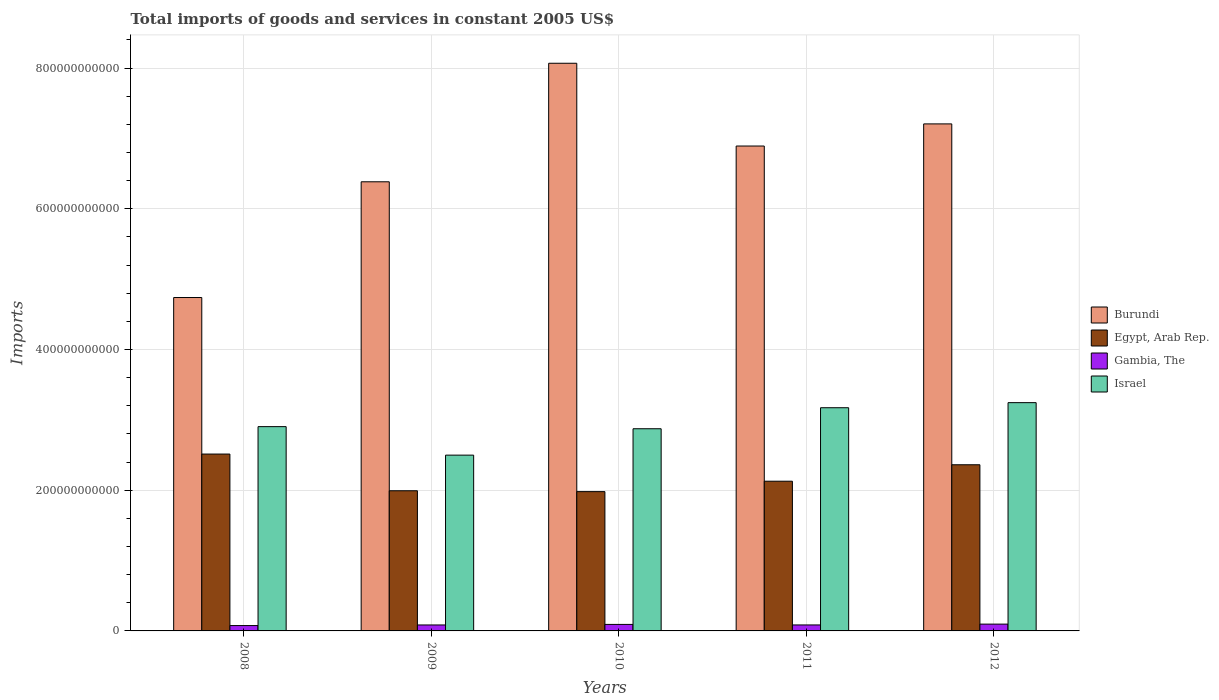How many different coloured bars are there?
Keep it short and to the point. 4. How many groups of bars are there?
Offer a terse response. 5. How many bars are there on the 5th tick from the right?
Keep it short and to the point. 4. What is the total imports of goods and services in Burundi in 2011?
Ensure brevity in your answer.  6.89e+11. Across all years, what is the maximum total imports of goods and services in Israel?
Your answer should be compact. 3.24e+11. Across all years, what is the minimum total imports of goods and services in Egypt, Arab Rep.?
Ensure brevity in your answer.  1.98e+11. In which year was the total imports of goods and services in Israel maximum?
Provide a short and direct response. 2012. What is the total total imports of goods and services in Egypt, Arab Rep. in the graph?
Your response must be concise. 1.10e+12. What is the difference between the total imports of goods and services in Israel in 2011 and that in 2012?
Give a very brief answer. -7.21e+09. What is the difference between the total imports of goods and services in Gambia, The in 2009 and the total imports of goods and services in Egypt, Arab Rep. in 2012?
Offer a terse response. -2.28e+11. What is the average total imports of goods and services in Egypt, Arab Rep. per year?
Your response must be concise. 2.19e+11. In the year 2009, what is the difference between the total imports of goods and services in Gambia, The and total imports of goods and services in Egypt, Arab Rep.?
Provide a succinct answer. -1.91e+11. In how many years, is the total imports of goods and services in Israel greater than 440000000000 US$?
Offer a terse response. 0. What is the ratio of the total imports of goods and services in Gambia, The in 2009 to that in 2012?
Keep it short and to the point. 0.87. What is the difference between the highest and the second highest total imports of goods and services in Egypt, Arab Rep.?
Provide a succinct answer. 1.52e+1. What is the difference between the highest and the lowest total imports of goods and services in Burundi?
Make the answer very short. 3.33e+11. In how many years, is the total imports of goods and services in Israel greater than the average total imports of goods and services in Israel taken over all years?
Your answer should be compact. 2. Is the sum of the total imports of goods and services in Egypt, Arab Rep. in 2008 and 2010 greater than the maximum total imports of goods and services in Burundi across all years?
Your response must be concise. No. Is it the case that in every year, the sum of the total imports of goods and services in Gambia, The and total imports of goods and services in Israel is greater than the sum of total imports of goods and services in Burundi and total imports of goods and services in Egypt, Arab Rep.?
Provide a succinct answer. No. What does the 3rd bar from the left in 2010 represents?
Offer a terse response. Gambia, The. What does the 3rd bar from the right in 2011 represents?
Your response must be concise. Egypt, Arab Rep. How many bars are there?
Offer a terse response. 20. What is the difference between two consecutive major ticks on the Y-axis?
Ensure brevity in your answer.  2.00e+11. Are the values on the major ticks of Y-axis written in scientific E-notation?
Ensure brevity in your answer.  No. Does the graph contain grids?
Keep it short and to the point. Yes. What is the title of the graph?
Offer a terse response. Total imports of goods and services in constant 2005 US$. Does "Belgium" appear as one of the legend labels in the graph?
Offer a terse response. No. What is the label or title of the Y-axis?
Your answer should be very brief. Imports. What is the Imports of Burundi in 2008?
Provide a succinct answer. 4.74e+11. What is the Imports in Egypt, Arab Rep. in 2008?
Provide a short and direct response. 2.51e+11. What is the Imports in Gambia, The in 2008?
Provide a short and direct response. 7.61e+09. What is the Imports in Israel in 2008?
Offer a terse response. 2.90e+11. What is the Imports in Burundi in 2009?
Provide a short and direct response. 6.38e+11. What is the Imports of Egypt, Arab Rep. in 2009?
Offer a very short reply. 1.99e+11. What is the Imports in Gambia, The in 2009?
Offer a terse response. 8.47e+09. What is the Imports of Israel in 2009?
Provide a short and direct response. 2.50e+11. What is the Imports of Burundi in 2010?
Offer a terse response. 8.07e+11. What is the Imports in Egypt, Arab Rep. in 2010?
Ensure brevity in your answer.  1.98e+11. What is the Imports in Gambia, The in 2010?
Your answer should be compact. 9.24e+09. What is the Imports in Israel in 2010?
Ensure brevity in your answer.  2.87e+11. What is the Imports of Burundi in 2011?
Provide a succinct answer. 6.89e+11. What is the Imports in Egypt, Arab Rep. in 2011?
Make the answer very short. 2.13e+11. What is the Imports of Gambia, The in 2011?
Your response must be concise. 8.50e+09. What is the Imports in Israel in 2011?
Keep it short and to the point. 3.17e+11. What is the Imports of Burundi in 2012?
Your answer should be compact. 7.21e+11. What is the Imports in Egypt, Arab Rep. in 2012?
Your answer should be very brief. 2.36e+11. What is the Imports of Gambia, The in 2012?
Offer a very short reply. 9.68e+09. What is the Imports in Israel in 2012?
Provide a succinct answer. 3.24e+11. Across all years, what is the maximum Imports of Burundi?
Provide a succinct answer. 8.07e+11. Across all years, what is the maximum Imports in Egypt, Arab Rep.?
Make the answer very short. 2.51e+11. Across all years, what is the maximum Imports in Gambia, The?
Make the answer very short. 9.68e+09. Across all years, what is the maximum Imports in Israel?
Offer a very short reply. 3.24e+11. Across all years, what is the minimum Imports of Burundi?
Keep it short and to the point. 4.74e+11. Across all years, what is the minimum Imports in Egypt, Arab Rep.?
Your response must be concise. 1.98e+11. Across all years, what is the minimum Imports in Gambia, The?
Provide a short and direct response. 7.61e+09. Across all years, what is the minimum Imports of Israel?
Ensure brevity in your answer.  2.50e+11. What is the total Imports of Burundi in the graph?
Offer a very short reply. 3.33e+12. What is the total Imports in Egypt, Arab Rep. in the graph?
Give a very brief answer. 1.10e+12. What is the total Imports of Gambia, The in the graph?
Ensure brevity in your answer.  4.35e+1. What is the total Imports in Israel in the graph?
Your answer should be very brief. 1.47e+12. What is the difference between the Imports in Burundi in 2008 and that in 2009?
Give a very brief answer. -1.64e+11. What is the difference between the Imports in Egypt, Arab Rep. in 2008 and that in 2009?
Your answer should be very brief. 5.22e+1. What is the difference between the Imports of Gambia, The in 2008 and that in 2009?
Offer a very short reply. -8.61e+08. What is the difference between the Imports in Israel in 2008 and that in 2009?
Your response must be concise. 4.05e+1. What is the difference between the Imports in Burundi in 2008 and that in 2010?
Offer a very short reply. -3.33e+11. What is the difference between the Imports in Egypt, Arab Rep. in 2008 and that in 2010?
Provide a succinct answer. 5.34e+1. What is the difference between the Imports in Gambia, The in 2008 and that in 2010?
Your response must be concise. -1.63e+09. What is the difference between the Imports of Israel in 2008 and that in 2010?
Keep it short and to the point. 2.99e+09. What is the difference between the Imports in Burundi in 2008 and that in 2011?
Your answer should be compact. -2.15e+11. What is the difference between the Imports in Egypt, Arab Rep. in 2008 and that in 2011?
Give a very brief answer. 3.86e+1. What is the difference between the Imports of Gambia, The in 2008 and that in 2011?
Your response must be concise. -8.95e+08. What is the difference between the Imports in Israel in 2008 and that in 2011?
Your answer should be compact. -2.69e+1. What is the difference between the Imports in Burundi in 2008 and that in 2012?
Ensure brevity in your answer.  -2.47e+11. What is the difference between the Imports of Egypt, Arab Rep. in 2008 and that in 2012?
Make the answer very short. 1.52e+1. What is the difference between the Imports in Gambia, The in 2008 and that in 2012?
Your answer should be compact. -2.07e+09. What is the difference between the Imports in Israel in 2008 and that in 2012?
Provide a succinct answer. -3.41e+1. What is the difference between the Imports in Burundi in 2009 and that in 2010?
Provide a succinct answer. -1.68e+11. What is the difference between the Imports in Egypt, Arab Rep. in 2009 and that in 2010?
Provide a short and direct response. 1.24e+09. What is the difference between the Imports in Gambia, The in 2009 and that in 2010?
Provide a short and direct response. -7.72e+08. What is the difference between the Imports of Israel in 2009 and that in 2010?
Your response must be concise. -3.75e+1. What is the difference between the Imports in Burundi in 2009 and that in 2011?
Your response must be concise. -5.08e+1. What is the difference between the Imports in Egypt, Arab Rep. in 2009 and that in 2011?
Keep it short and to the point. -1.36e+1. What is the difference between the Imports in Gambia, The in 2009 and that in 2011?
Keep it short and to the point. -3.38e+07. What is the difference between the Imports in Israel in 2009 and that in 2011?
Your answer should be very brief. -6.74e+1. What is the difference between the Imports of Burundi in 2009 and that in 2012?
Give a very brief answer. -8.23e+1. What is the difference between the Imports in Egypt, Arab Rep. in 2009 and that in 2012?
Offer a very short reply. -3.70e+1. What is the difference between the Imports of Gambia, The in 2009 and that in 2012?
Offer a very short reply. -1.21e+09. What is the difference between the Imports of Israel in 2009 and that in 2012?
Your answer should be compact. -7.46e+1. What is the difference between the Imports of Burundi in 2010 and that in 2011?
Provide a short and direct response. 1.18e+11. What is the difference between the Imports of Egypt, Arab Rep. in 2010 and that in 2011?
Your answer should be compact. -1.48e+1. What is the difference between the Imports of Gambia, The in 2010 and that in 2011?
Ensure brevity in your answer.  7.38e+08. What is the difference between the Imports of Israel in 2010 and that in 2011?
Offer a very short reply. -2.99e+1. What is the difference between the Imports of Burundi in 2010 and that in 2012?
Offer a very short reply. 8.62e+1. What is the difference between the Imports in Egypt, Arab Rep. in 2010 and that in 2012?
Offer a very short reply. -3.82e+1. What is the difference between the Imports in Gambia, The in 2010 and that in 2012?
Ensure brevity in your answer.  -4.40e+08. What is the difference between the Imports of Israel in 2010 and that in 2012?
Make the answer very short. -3.71e+1. What is the difference between the Imports of Burundi in 2011 and that in 2012?
Give a very brief answer. -3.15e+1. What is the difference between the Imports in Egypt, Arab Rep. in 2011 and that in 2012?
Give a very brief answer. -2.34e+1. What is the difference between the Imports of Gambia, The in 2011 and that in 2012?
Offer a terse response. -1.18e+09. What is the difference between the Imports of Israel in 2011 and that in 2012?
Provide a short and direct response. -7.21e+09. What is the difference between the Imports of Burundi in 2008 and the Imports of Egypt, Arab Rep. in 2009?
Provide a succinct answer. 2.75e+11. What is the difference between the Imports of Burundi in 2008 and the Imports of Gambia, The in 2009?
Keep it short and to the point. 4.65e+11. What is the difference between the Imports in Burundi in 2008 and the Imports in Israel in 2009?
Give a very brief answer. 2.24e+11. What is the difference between the Imports in Egypt, Arab Rep. in 2008 and the Imports in Gambia, The in 2009?
Your answer should be very brief. 2.43e+11. What is the difference between the Imports in Egypt, Arab Rep. in 2008 and the Imports in Israel in 2009?
Your response must be concise. 1.55e+09. What is the difference between the Imports in Gambia, The in 2008 and the Imports in Israel in 2009?
Give a very brief answer. -2.42e+11. What is the difference between the Imports in Burundi in 2008 and the Imports in Egypt, Arab Rep. in 2010?
Make the answer very short. 2.76e+11. What is the difference between the Imports of Burundi in 2008 and the Imports of Gambia, The in 2010?
Your response must be concise. 4.65e+11. What is the difference between the Imports in Burundi in 2008 and the Imports in Israel in 2010?
Ensure brevity in your answer.  1.87e+11. What is the difference between the Imports of Egypt, Arab Rep. in 2008 and the Imports of Gambia, The in 2010?
Your response must be concise. 2.42e+11. What is the difference between the Imports of Egypt, Arab Rep. in 2008 and the Imports of Israel in 2010?
Provide a succinct answer. -3.60e+1. What is the difference between the Imports of Gambia, The in 2008 and the Imports of Israel in 2010?
Your response must be concise. -2.80e+11. What is the difference between the Imports of Burundi in 2008 and the Imports of Egypt, Arab Rep. in 2011?
Ensure brevity in your answer.  2.61e+11. What is the difference between the Imports of Burundi in 2008 and the Imports of Gambia, The in 2011?
Your answer should be compact. 4.65e+11. What is the difference between the Imports of Burundi in 2008 and the Imports of Israel in 2011?
Provide a short and direct response. 1.57e+11. What is the difference between the Imports of Egypt, Arab Rep. in 2008 and the Imports of Gambia, The in 2011?
Give a very brief answer. 2.43e+11. What is the difference between the Imports in Egypt, Arab Rep. in 2008 and the Imports in Israel in 2011?
Offer a very short reply. -6.58e+1. What is the difference between the Imports in Gambia, The in 2008 and the Imports in Israel in 2011?
Offer a very short reply. -3.10e+11. What is the difference between the Imports of Burundi in 2008 and the Imports of Egypt, Arab Rep. in 2012?
Your response must be concise. 2.38e+11. What is the difference between the Imports in Burundi in 2008 and the Imports in Gambia, The in 2012?
Offer a very short reply. 4.64e+11. What is the difference between the Imports of Burundi in 2008 and the Imports of Israel in 2012?
Ensure brevity in your answer.  1.49e+11. What is the difference between the Imports in Egypt, Arab Rep. in 2008 and the Imports in Gambia, The in 2012?
Give a very brief answer. 2.42e+11. What is the difference between the Imports of Egypt, Arab Rep. in 2008 and the Imports of Israel in 2012?
Provide a short and direct response. -7.31e+1. What is the difference between the Imports in Gambia, The in 2008 and the Imports in Israel in 2012?
Offer a very short reply. -3.17e+11. What is the difference between the Imports of Burundi in 2009 and the Imports of Egypt, Arab Rep. in 2010?
Offer a very short reply. 4.40e+11. What is the difference between the Imports of Burundi in 2009 and the Imports of Gambia, The in 2010?
Your response must be concise. 6.29e+11. What is the difference between the Imports of Burundi in 2009 and the Imports of Israel in 2010?
Your answer should be compact. 3.51e+11. What is the difference between the Imports of Egypt, Arab Rep. in 2009 and the Imports of Gambia, The in 2010?
Ensure brevity in your answer.  1.90e+11. What is the difference between the Imports in Egypt, Arab Rep. in 2009 and the Imports in Israel in 2010?
Ensure brevity in your answer.  -8.81e+1. What is the difference between the Imports in Gambia, The in 2009 and the Imports in Israel in 2010?
Offer a very short reply. -2.79e+11. What is the difference between the Imports of Burundi in 2009 and the Imports of Egypt, Arab Rep. in 2011?
Keep it short and to the point. 4.26e+11. What is the difference between the Imports of Burundi in 2009 and the Imports of Gambia, The in 2011?
Offer a terse response. 6.30e+11. What is the difference between the Imports in Burundi in 2009 and the Imports in Israel in 2011?
Provide a succinct answer. 3.21e+11. What is the difference between the Imports of Egypt, Arab Rep. in 2009 and the Imports of Gambia, The in 2011?
Offer a very short reply. 1.91e+11. What is the difference between the Imports in Egypt, Arab Rep. in 2009 and the Imports in Israel in 2011?
Ensure brevity in your answer.  -1.18e+11. What is the difference between the Imports in Gambia, The in 2009 and the Imports in Israel in 2011?
Offer a terse response. -3.09e+11. What is the difference between the Imports in Burundi in 2009 and the Imports in Egypt, Arab Rep. in 2012?
Keep it short and to the point. 4.02e+11. What is the difference between the Imports of Burundi in 2009 and the Imports of Gambia, The in 2012?
Your answer should be very brief. 6.29e+11. What is the difference between the Imports of Burundi in 2009 and the Imports of Israel in 2012?
Offer a terse response. 3.14e+11. What is the difference between the Imports in Egypt, Arab Rep. in 2009 and the Imports in Gambia, The in 2012?
Offer a terse response. 1.90e+11. What is the difference between the Imports in Egypt, Arab Rep. in 2009 and the Imports in Israel in 2012?
Give a very brief answer. -1.25e+11. What is the difference between the Imports in Gambia, The in 2009 and the Imports in Israel in 2012?
Ensure brevity in your answer.  -3.16e+11. What is the difference between the Imports of Burundi in 2010 and the Imports of Egypt, Arab Rep. in 2011?
Keep it short and to the point. 5.94e+11. What is the difference between the Imports of Burundi in 2010 and the Imports of Gambia, The in 2011?
Ensure brevity in your answer.  7.98e+11. What is the difference between the Imports of Burundi in 2010 and the Imports of Israel in 2011?
Offer a very short reply. 4.90e+11. What is the difference between the Imports in Egypt, Arab Rep. in 2010 and the Imports in Gambia, The in 2011?
Your answer should be compact. 1.89e+11. What is the difference between the Imports in Egypt, Arab Rep. in 2010 and the Imports in Israel in 2011?
Give a very brief answer. -1.19e+11. What is the difference between the Imports of Gambia, The in 2010 and the Imports of Israel in 2011?
Give a very brief answer. -3.08e+11. What is the difference between the Imports in Burundi in 2010 and the Imports in Egypt, Arab Rep. in 2012?
Give a very brief answer. 5.71e+11. What is the difference between the Imports in Burundi in 2010 and the Imports in Gambia, The in 2012?
Keep it short and to the point. 7.97e+11. What is the difference between the Imports in Burundi in 2010 and the Imports in Israel in 2012?
Your answer should be compact. 4.82e+11. What is the difference between the Imports of Egypt, Arab Rep. in 2010 and the Imports of Gambia, The in 2012?
Provide a short and direct response. 1.88e+11. What is the difference between the Imports in Egypt, Arab Rep. in 2010 and the Imports in Israel in 2012?
Your answer should be compact. -1.26e+11. What is the difference between the Imports of Gambia, The in 2010 and the Imports of Israel in 2012?
Give a very brief answer. -3.15e+11. What is the difference between the Imports in Burundi in 2011 and the Imports in Egypt, Arab Rep. in 2012?
Provide a succinct answer. 4.53e+11. What is the difference between the Imports in Burundi in 2011 and the Imports in Gambia, The in 2012?
Your answer should be very brief. 6.79e+11. What is the difference between the Imports of Burundi in 2011 and the Imports of Israel in 2012?
Your response must be concise. 3.65e+11. What is the difference between the Imports in Egypt, Arab Rep. in 2011 and the Imports in Gambia, The in 2012?
Ensure brevity in your answer.  2.03e+11. What is the difference between the Imports of Egypt, Arab Rep. in 2011 and the Imports of Israel in 2012?
Your answer should be compact. -1.12e+11. What is the difference between the Imports in Gambia, The in 2011 and the Imports in Israel in 2012?
Your answer should be compact. -3.16e+11. What is the average Imports in Burundi per year?
Give a very brief answer. 6.66e+11. What is the average Imports in Egypt, Arab Rep. per year?
Make the answer very short. 2.19e+11. What is the average Imports of Gambia, The per year?
Offer a very short reply. 8.70e+09. What is the average Imports of Israel per year?
Provide a short and direct response. 2.94e+11. In the year 2008, what is the difference between the Imports of Burundi and Imports of Egypt, Arab Rep.?
Offer a very short reply. 2.22e+11. In the year 2008, what is the difference between the Imports in Burundi and Imports in Gambia, The?
Make the answer very short. 4.66e+11. In the year 2008, what is the difference between the Imports in Burundi and Imports in Israel?
Offer a very short reply. 1.84e+11. In the year 2008, what is the difference between the Imports of Egypt, Arab Rep. and Imports of Gambia, The?
Your response must be concise. 2.44e+11. In the year 2008, what is the difference between the Imports in Egypt, Arab Rep. and Imports in Israel?
Ensure brevity in your answer.  -3.90e+1. In the year 2008, what is the difference between the Imports of Gambia, The and Imports of Israel?
Your response must be concise. -2.83e+11. In the year 2009, what is the difference between the Imports of Burundi and Imports of Egypt, Arab Rep.?
Ensure brevity in your answer.  4.39e+11. In the year 2009, what is the difference between the Imports in Burundi and Imports in Gambia, The?
Keep it short and to the point. 6.30e+11. In the year 2009, what is the difference between the Imports in Burundi and Imports in Israel?
Offer a very short reply. 3.88e+11. In the year 2009, what is the difference between the Imports of Egypt, Arab Rep. and Imports of Gambia, The?
Your answer should be very brief. 1.91e+11. In the year 2009, what is the difference between the Imports of Egypt, Arab Rep. and Imports of Israel?
Ensure brevity in your answer.  -5.06e+1. In the year 2009, what is the difference between the Imports in Gambia, The and Imports in Israel?
Make the answer very short. -2.41e+11. In the year 2010, what is the difference between the Imports of Burundi and Imports of Egypt, Arab Rep.?
Your answer should be compact. 6.09e+11. In the year 2010, what is the difference between the Imports of Burundi and Imports of Gambia, The?
Provide a succinct answer. 7.98e+11. In the year 2010, what is the difference between the Imports in Burundi and Imports in Israel?
Keep it short and to the point. 5.19e+11. In the year 2010, what is the difference between the Imports in Egypt, Arab Rep. and Imports in Gambia, The?
Provide a succinct answer. 1.89e+11. In the year 2010, what is the difference between the Imports in Egypt, Arab Rep. and Imports in Israel?
Make the answer very short. -8.94e+1. In the year 2010, what is the difference between the Imports of Gambia, The and Imports of Israel?
Offer a terse response. -2.78e+11. In the year 2011, what is the difference between the Imports in Burundi and Imports in Egypt, Arab Rep.?
Provide a short and direct response. 4.76e+11. In the year 2011, what is the difference between the Imports in Burundi and Imports in Gambia, The?
Provide a short and direct response. 6.81e+11. In the year 2011, what is the difference between the Imports in Burundi and Imports in Israel?
Provide a succinct answer. 3.72e+11. In the year 2011, what is the difference between the Imports of Egypt, Arab Rep. and Imports of Gambia, The?
Ensure brevity in your answer.  2.04e+11. In the year 2011, what is the difference between the Imports in Egypt, Arab Rep. and Imports in Israel?
Give a very brief answer. -1.04e+11. In the year 2011, what is the difference between the Imports of Gambia, The and Imports of Israel?
Give a very brief answer. -3.09e+11. In the year 2012, what is the difference between the Imports of Burundi and Imports of Egypt, Arab Rep.?
Offer a terse response. 4.84e+11. In the year 2012, what is the difference between the Imports in Burundi and Imports in Gambia, The?
Ensure brevity in your answer.  7.11e+11. In the year 2012, what is the difference between the Imports of Burundi and Imports of Israel?
Provide a succinct answer. 3.96e+11. In the year 2012, what is the difference between the Imports of Egypt, Arab Rep. and Imports of Gambia, The?
Keep it short and to the point. 2.26e+11. In the year 2012, what is the difference between the Imports in Egypt, Arab Rep. and Imports in Israel?
Provide a succinct answer. -8.83e+1. In the year 2012, what is the difference between the Imports in Gambia, The and Imports in Israel?
Provide a short and direct response. -3.15e+11. What is the ratio of the Imports of Burundi in 2008 to that in 2009?
Provide a succinct answer. 0.74. What is the ratio of the Imports in Egypt, Arab Rep. in 2008 to that in 2009?
Provide a short and direct response. 1.26. What is the ratio of the Imports in Gambia, The in 2008 to that in 2009?
Offer a very short reply. 0.9. What is the ratio of the Imports of Israel in 2008 to that in 2009?
Offer a very short reply. 1.16. What is the ratio of the Imports of Burundi in 2008 to that in 2010?
Offer a very short reply. 0.59. What is the ratio of the Imports in Egypt, Arab Rep. in 2008 to that in 2010?
Give a very brief answer. 1.27. What is the ratio of the Imports of Gambia, The in 2008 to that in 2010?
Make the answer very short. 0.82. What is the ratio of the Imports of Israel in 2008 to that in 2010?
Ensure brevity in your answer.  1.01. What is the ratio of the Imports of Burundi in 2008 to that in 2011?
Provide a succinct answer. 0.69. What is the ratio of the Imports in Egypt, Arab Rep. in 2008 to that in 2011?
Provide a succinct answer. 1.18. What is the ratio of the Imports of Gambia, The in 2008 to that in 2011?
Your response must be concise. 0.89. What is the ratio of the Imports in Israel in 2008 to that in 2011?
Ensure brevity in your answer.  0.92. What is the ratio of the Imports of Burundi in 2008 to that in 2012?
Keep it short and to the point. 0.66. What is the ratio of the Imports in Egypt, Arab Rep. in 2008 to that in 2012?
Make the answer very short. 1.06. What is the ratio of the Imports in Gambia, The in 2008 to that in 2012?
Offer a terse response. 0.79. What is the ratio of the Imports of Israel in 2008 to that in 2012?
Your answer should be very brief. 0.89. What is the ratio of the Imports of Burundi in 2009 to that in 2010?
Offer a very short reply. 0.79. What is the ratio of the Imports in Gambia, The in 2009 to that in 2010?
Ensure brevity in your answer.  0.92. What is the ratio of the Imports in Israel in 2009 to that in 2010?
Ensure brevity in your answer.  0.87. What is the ratio of the Imports in Burundi in 2009 to that in 2011?
Offer a terse response. 0.93. What is the ratio of the Imports in Egypt, Arab Rep. in 2009 to that in 2011?
Provide a succinct answer. 0.94. What is the ratio of the Imports of Gambia, The in 2009 to that in 2011?
Ensure brevity in your answer.  1. What is the ratio of the Imports of Israel in 2009 to that in 2011?
Give a very brief answer. 0.79. What is the ratio of the Imports of Burundi in 2009 to that in 2012?
Offer a terse response. 0.89. What is the ratio of the Imports of Egypt, Arab Rep. in 2009 to that in 2012?
Ensure brevity in your answer.  0.84. What is the ratio of the Imports in Gambia, The in 2009 to that in 2012?
Make the answer very short. 0.87. What is the ratio of the Imports of Israel in 2009 to that in 2012?
Provide a short and direct response. 0.77. What is the ratio of the Imports in Burundi in 2010 to that in 2011?
Ensure brevity in your answer.  1.17. What is the ratio of the Imports of Egypt, Arab Rep. in 2010 to that in 2011?
Your answer should be compact. 0.93. What is the ratio of the Imports in Gambia, The in 2010 to that in 2011?
Your answer should be compact. 1.09. What is the ratio of the Imports of Israel in 2010 to that in 2011?
Your response must be concise. 0.91. What is the ratio of the Imports in Burundi in 2010 to that in 2012?
Offer a very short reply. 1.12. What is the ratio of the Imports of Egypt, Arab Rep. in 2010 to that in 2012?
Your response must be concise. 0.84. What is the ratio of the Imports in Gambia, The in 2010 to that in 2012?
Ensure brevity in your answer.  0.95. What is the ratio of the Imports in Israel in 2010 to that in 2012?
Give a very brief answer. 0.89. What is the ratio of the Imports of Burundi in 2011 to that in 2012?
Your response must be concise. 0.96. What is the ratio of the Imports of Egypt, Arab Rep. in 2011 to that in 2012?
Keep it short and to the point. 0.9. What is the ratio of the Imports in Gambia, The in 2011 to that in 2012?
Your response must be concise. 0.88. What is the ratio of the Imports in Israel in 2011 to that in 2012?
Provide a short and direct response. 0.98. What is the difference between the highest and the second highest Imports in Burundi?
Your response must be concise. 8.62e+1. What is the difference between the highest and the second highest Imports in Egypt, Arab Rep.?
Offer a very short reply. 1.52e+1. What is the difference between the highest and the second highest Imports in Gambia, The?
Provide a short and direct response. 4.40e+08. What is the difference between the highest and the second highest Imports in Israel?
Your answer should be compact. 7.21e+09. What is the difference between the highest and the lowest Imports of Burundi?
Give a very brief answer. 3.33e+11. What is the difference between the highest and the lowest Imports of Egypt, Arab Rep.?
Your answer should be very brief. 5.34e+1. What is the difference between the highest and the lowest Imports of Gambia, The?
Your answer should be very brief. 2.07e+09. What is the difference between the highest and the lowest Imports of Israel?
Provide a short and direct response. 7.46e+1. 